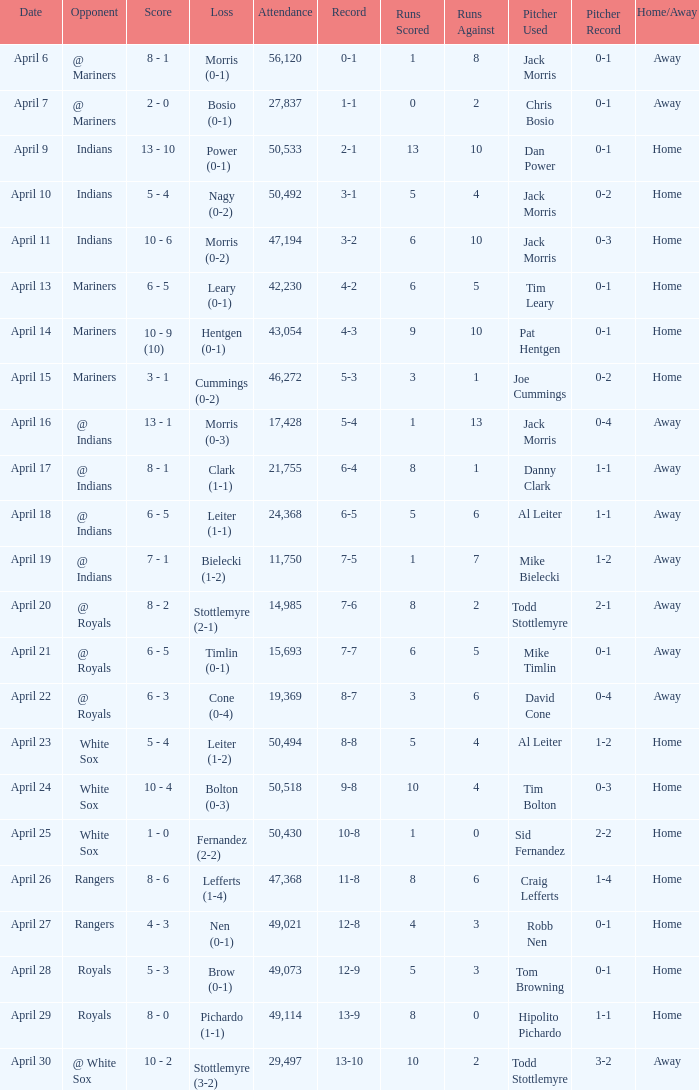What scored is recorded on April 24? 10 - 4. 